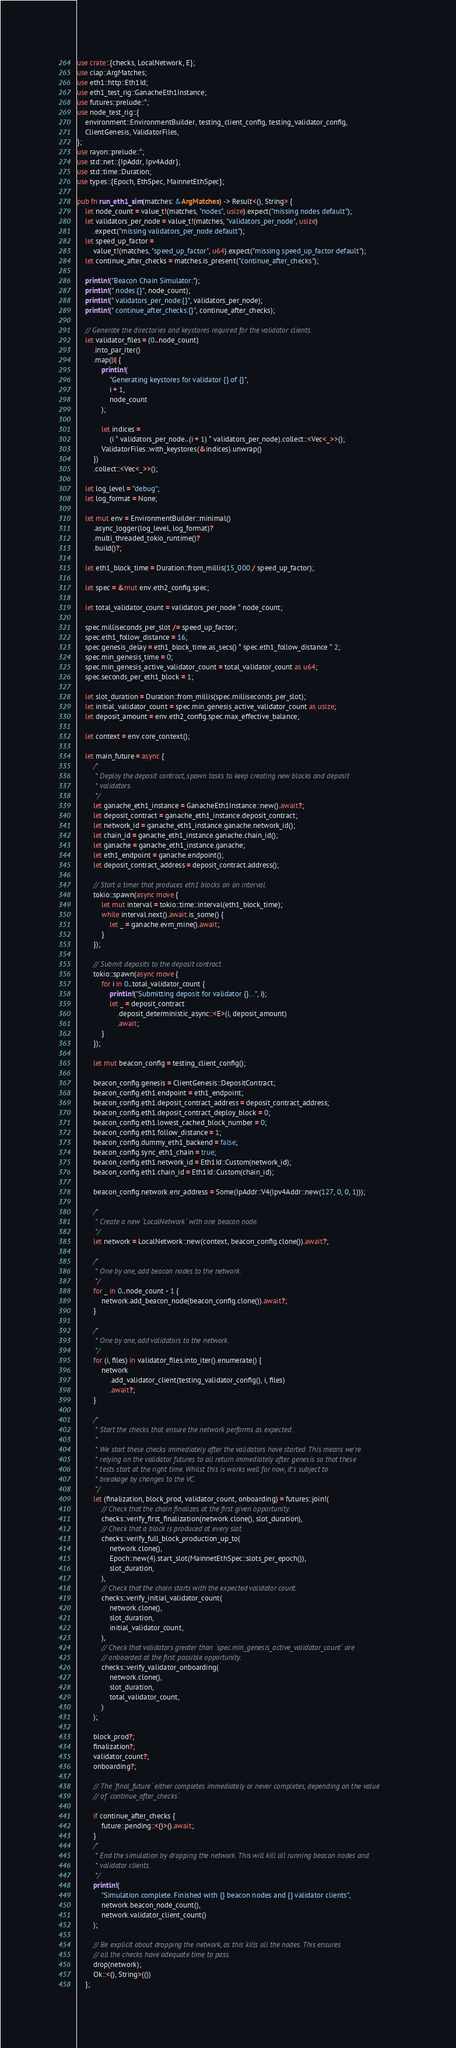<code> <loc_0><loc_0><loc_500><loc_500><_Rust_>use crate::{checks, LocalNetwork, E};
use clap::ArgMatches;
use eth1::http::Eth1Id;
use eth1_test_rig::GanacheEth1Instance;
use futures::prelude::*;
use node_test_rig::{
    environment::EnvironmentBuilder, testing_client_config, testing_validator_config,
    ClientGenesis, ValidatorFiles,
};
use rayon::prelude::*;
use std::net::{IpAddr, Ipv4Addr};
use std::time::Duration;
use types::{Epoch, EthSpec, MainnetEthSpec};

pub fn run_eth1_sim(matches: &ArgMatches) -> Result<(), String> {
    let node_count = value_t!(matches, "nodes", usize).expect("missing nodes default");
    let validators_per_node = value_t!(matches, "validators_per_node", usize)
        .expect("missing validators_per_node default");
    let speed_up_factor =
        value_t!(matches, "speed_up_factor", u64).expect("missing speed_up_factor default");
    let continue_after_checks = matches.is_present("continue_after_checks");

    println!("Beacon Chain Simulator:");
    println!(" nodes:{}", node_count);
    println!(" validators_per_node:{}", validators_per_node);
    println!(" continue_after_checks:{}", continue_after_checks);

    // Generate the directories and keystores required for the validator clients.
    let validator_files = (0..node_count)
        .into_par_iter()
        .map(|i| {
            println!(
                "Generating keystores for validator {} of {}",
                i + 1,
                node_count
            );

            let indices =
                (i * validators_per_node..(i + 1) * validators_per_node).collect::<Vec<_>>();
            ValidatorFiles::with_keystores(&indices).unwrap()
        })
        .collect::<Vec<_>>();

    let log_level = "debug";
    let log_format = None;

    let mut env = EnvironmentBuilder::minimal()
        .async_logger(log_level, log_format)?
        .multi_threaded_tokio_runtime()?
        .build()?;

    let eth1_block_time = Duration::from_millis(15_000 / speed_up_factor);

    let spec = &mut env.eth2_config.spec;

    let total_validator_count = validators_per_node * node_count;

    spec.milliseconds_per_slot /= speed_up_factor;
    spec.eth1_follow_distance = 16;
    spec.genesis_delay = eth1_block_time.as_secs() * spec.eth1_follow_distance * 2;
    spec.min_genesis_time = 0;
    spec.min_genesis_active_validator_count = total_validator_count as u64;
    spec.seconds_per_eth1_block = 1;

    let slot_duration = Duration::from_millis(spec.milliseconds_per_slot);
    let initial_validator_count = spec.min_genesis_active_validator_count as usize;
    let deposit_amount = env.eth2_config.spec.max_effective_balance;

    let context = env.core_context();

    let main_future = async {
        /*
         * Deploy the deposit contract, spawn tasks to keep creating new blocks and deposit
         * validators.
         */
        let ganache_eth1_instance = GanacheEth1Instance::new().await?;
        let deposit_contract = ganache_eth1_instance.deposit_contract;
        let network_id = ganache_eth1_instance.ganache.network_id();
        let chain_id = ganache_eth1_instance.ganache.chain_id();
        let ganache = ganache_eth1_instance.ganache;
        let eth1_endpoint = ganache.endpoint();
        let deposit_contract_address = deposit_contract.address();

        // Start a timer that produces eth1 blocks on an interval.
        tokio::spawn(async move {
            let mut interval = tokio::time::interval(eth1_block_time);
            while interval.next().await.is_some() {
                let _ = ganache.evm_mine().await;
            }
        });

        // Submit deposits to the deposit contract.
        tokio::spawn(async move {
            for i in 0..total_validator_count {
                println!("Submitting deposit for validator {}...", i);
                let _ = deposit_contract
                    .deposit_deterministic_async::<E>(i, deposit_amount)
                    .await;
            }
        });

        let mut beacon_config = testing_client_config();

        beacon_config.genesis = ClientGenesis::DepositContract;
        beacon_config.eth1.endpoint = eth1_endpoint;
        beacon_config.eth1.deposit_contract_address = deposit_contract_address;
        beacon_config.eth1.deposit_contract_deploy_block = 0;
        beacon_config.eth1.lowest_cached_block_number = 0;
        beacon_config.eth1.follow_distance = 1;
        beacon_config.dummy_eth1_backend = false;
        beacon_config.sync_eth1_chain = true;
        beacon_config.eth1.network_id = Eth1Id::Custom(network_id);
        beacon_config.eth1.chain_id = Eth1Id::Custom(chain_id);

        beacon_config.network.enr_address = Some(IpAddr::V4(Ipv4Addr::new(127, 0, 0, 1)));

        /*
         * Create a new `LocalNetwork` with one beacon node.
         */
        let network = LocalNetwork::new(context, beacon_config.clone()).await?;

        /*
         * One by one, add beacon nodes to the network.
         */
        for _ in 0..node_count - 1 {
            network.add_beacon_node(beacon_config.clone()).await?;
        }

        /*
         * One by one, add validators to the network.
         */
        for (i, files) in validator_files.into_iter().enumerate() {
            network
                .add_validator_client(testing_validator_config(), i, files)
                .await?;
        }

        /*
         * Start the checks that ensure the network performs as expected.
         *
         * We start these checks immediately after the validators have started. This means we're
         * relying on the validator futures to all return immediately after genesis so that these
         * tests start at the right time. Whilst this is works well for now, it's subject to
         * breakage by changes to the VC.
         */
        let (finalization, block_prod, validator_count, onboarding) = futures::join!(
            // Check that the chain finalizes at the first given opportunity.
            checks::verify_first_finalization(network.clone(), slot_duration),
            // Check that a block is produced at every slot.
            checks::verify_full_block_production_up_to(
                network.clone(),
                Epoch::new(4).start_slot(MainnetEthSpec::slots_per_epoch()),
                slot_duration,
            ),
            // Check that the chain starts with the expected validator count.
            checks::verify_initial_validator_count(
                network.clone(),
                slot_duration,
                initial_validator_count,
            ),
            // Check that validators greater than `spec.min_genesis_active_validator_count` are
            // onboarded at the first possible opportunity.
            checks::verify_validator_onboarding(
                network.clone(),
                slot_duration,
                total_validator_count,
            )
        );

        block_prod?;
        finalization?;
        validator_count?;
        onboarding?;

        // The `final_future` either completes immediately or never completes, depending on the value
        // of `continue_after_checks`.

        if continue_after_checks {
            future::pending::<()>().await;
        }
        /*
         * End the simulation by dropping the network. This will kill all running beacon nodes and
         * validator clients.
         */
        println!(
            "Simulation complete. Finished with {} beacon nodes and {} validator clients",
            network.beacon_node_count(),
            network.validator_client_count()
        );

        // Be explicit about dropping the network, as this kills all the nodes. This ensures
        // all the checks have adequate time to pass.
        drop(network);
        Ok::<(), String>(())
    };
</code> 